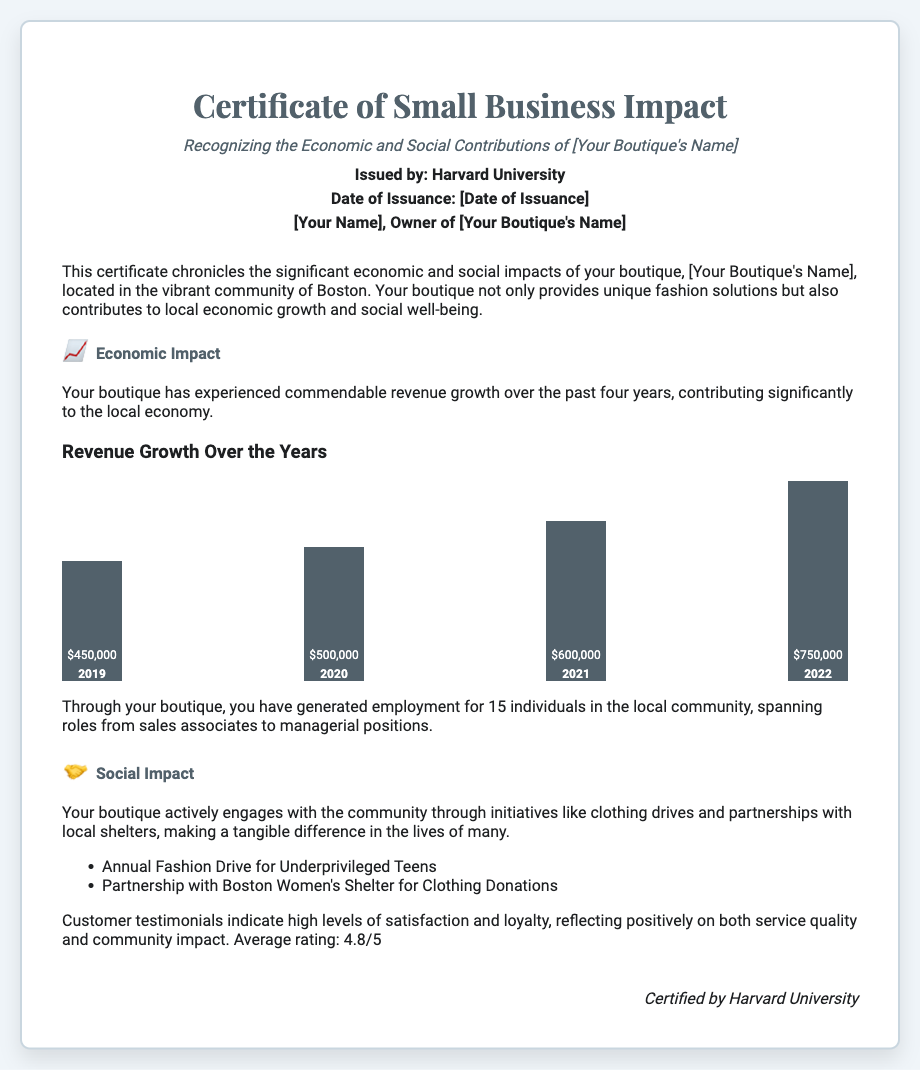What is the name of the boutique? The document mentions "[Your Boutique's Name]" as a placeholder for the actual boutique name, which should be filled in by the owner.
Answer: [Your Boutique's Name] Who issued the certificate? The document states that the certificate is issued by Harvard University.
Answer: Harvard University What was the revenue in 2021? The document provides specific revenue figures for each year, showing that the revenue in 2021 was $600,000.
Answer: $600,000 How many individuals does the boutique employ? The document mentions that the boutique has generated employment for 15 individuals.
Answer: 15 What was the average customer rating? The document indicates that the average customer rating is 4.8 out of 5.
Answer: 4.8/5 What community initiative does the boutique partake in? One of the community initiatives mentioned in the document is the "Annual Fashion Drive for Underprivileged Teens."
Answer: Annual Fashion Drive for Underprivileged Teens What revenue growth percentage is represented in the bar chart for 2022? By comparing the bar heights and revenue figures, we can see that the revenue in 2022 is the highest at $750,000.
Answer: 100% What is the date of issuance? The document placeholder states "[Date of Issuance]" which needs to be filled with the actual date.
Answer: [Date of Issuance] 